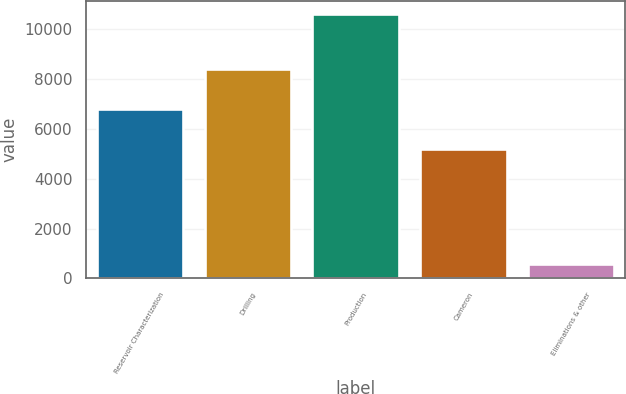Convert chart to OTSL. <chart><loc_0><loc_0><loc_500><loc_500><bar_chart><fcel>Reservoir Characterization<fcel>Drilling<fcel>Production<fcel>Cameron<fcel>Eliminations & other<nl><fcel>6795<fcel>8392<fcel>10630<fcel>5205<fcel>582<nl></chart> 